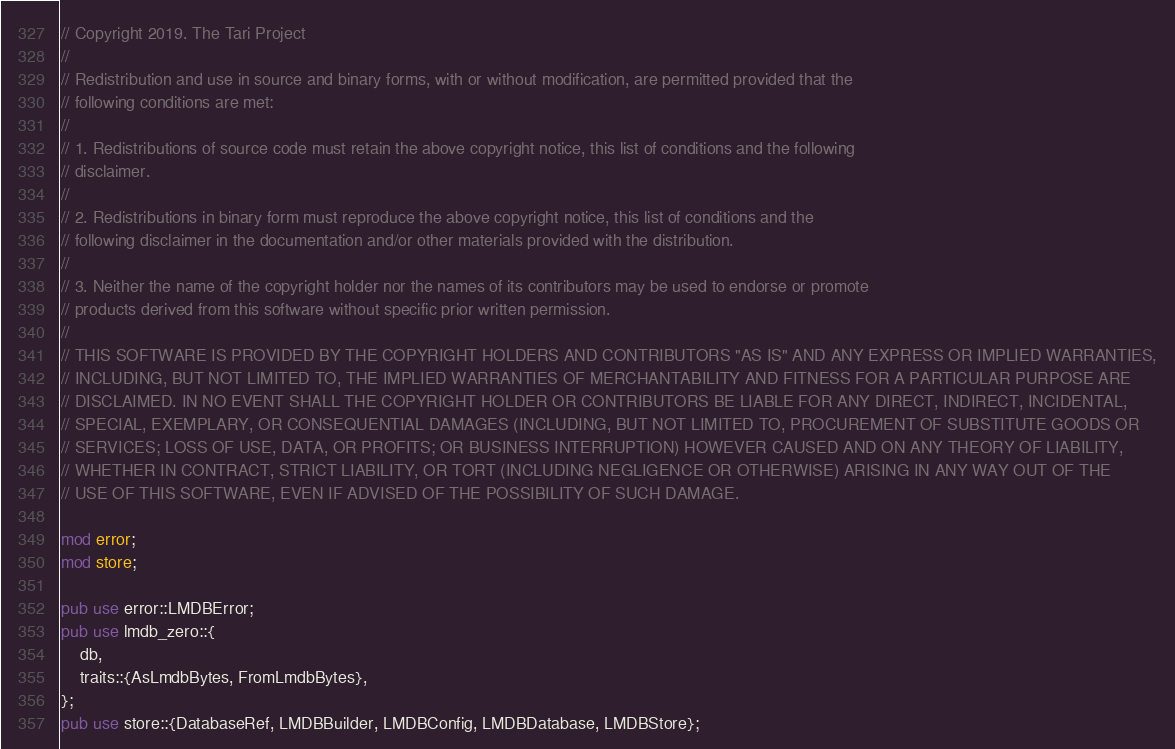Convert code to text. <code><loc_0><loc_0><loc_500><loc_500><_Rust_>// Copyright 2019. The Tari Project
//
// Redistribution and use in source and binary forms, with or without modification, are permitted provided that the
// following conditions are met:
//
// 1. Redistributions of source code must retain the above copyright notice, this list of conditions and the following
// disclaimer.
//
// 2. Redistributions in binary form must reproduce the above copyright notice, this list of conditions and the
// following disclaimer in the documentation and/or other materials provided with the distribution.
//
// 3. Neither the name of the copyright holder nor the names of its contributors may be used to endorse or promote
// products derived from this software without specific prior written permission.
//
// THIS SOFTWARE IS PROVIDED BY THE COPYRIGHT HOLDERS AND CONTRIBUTORS "AS IS" AND ANY EXPRESS OR IMPLIED WARRANTIES,
// INCLUDING, BUT NOT LIMITED TO, THE IMPLIED WARRANTIES OF MERCHANTABILITY AND FITNESS FOR A PARTICULAR PURPOSE ARE
// DISCLAIMED. IN NO EVENT SHALL THE COPYRIGHT HOLDER OR CONTRIBUTORS BE LIABLE FOR ANY DIRECT, INDIRECT, INCIDENTAL,
// SPECIAL, EXEMPLARY, OR CONSEQUENTIAL DAMAGES (INCLUDING, BUT NOT LIMITED TO, PROCUREMENT OF SUBSTITUTE GOODS OR
// SERVICES; LOSS OF USE, DATA, OR PROFITS; OR BUSINESS INTERRUPTION) HOWEVER CAUSED AND ON ANY THEORY OF LIABILITY,
// WHETHER IN CONTRACT, STRICT LIABILITY, OR TORT (INCLUDING NEGLIGENCE OR OTHERWISE) ARISING IN ANY WAY OUT OF THE
// USE OF THIS SOFTWARE, EVEN IF ADVISED OF THE POSSIBILITY OF SUCH DAMAGE.

mod error;
mod store;

pub use error::LMDBError;
pub use lmdb_zero::{
    db,
    traits::{AsLmdbBytes, FromLmdbBytes},
};
pub use store::{DatabaseRef, LMDBBuilder, LMDBConfig, LMDBDatabase, LMDBStore};
</code> 